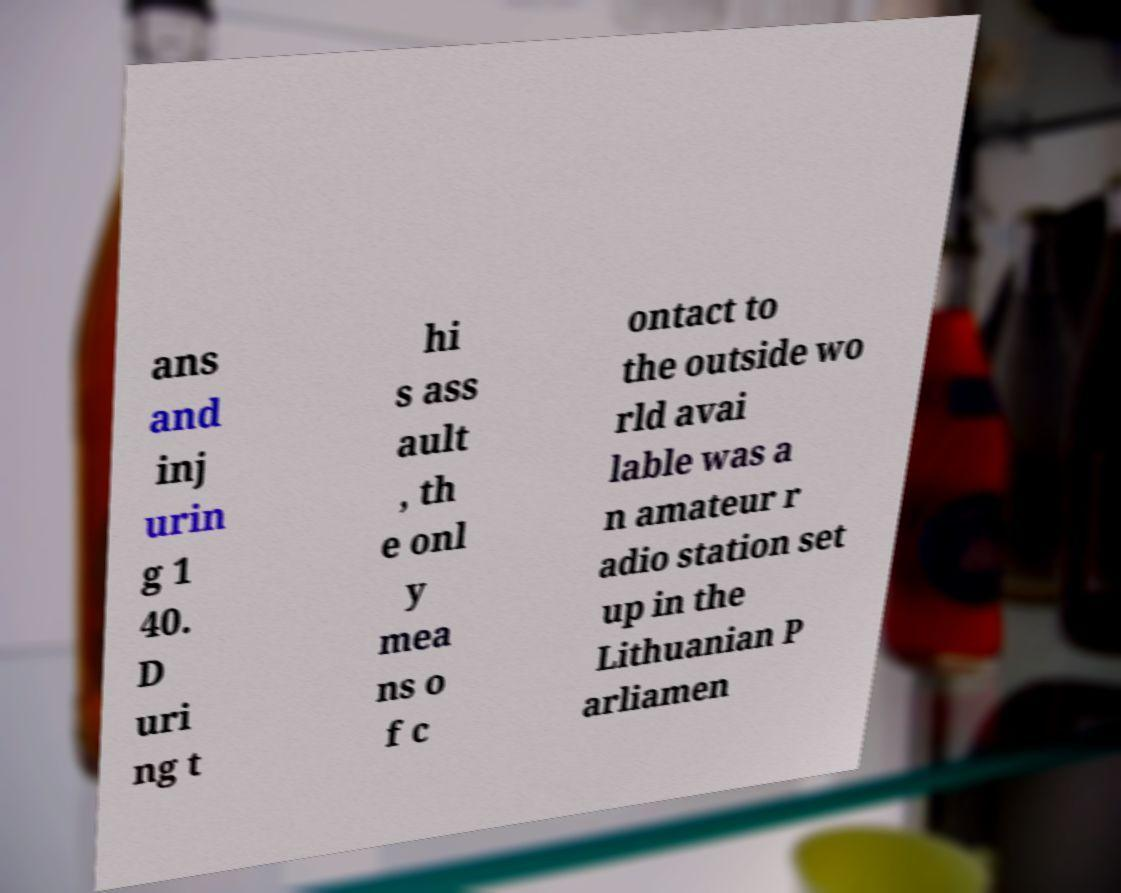Please identify and transcribe the text found in this image. ans and inj urin g 1 40. D uri ng t hi s ass ault , th e onl y mea ns o f c ontact to the outside wo rld avai lable was a n amateur r adio station set up in the Lithuanian P arliamen 